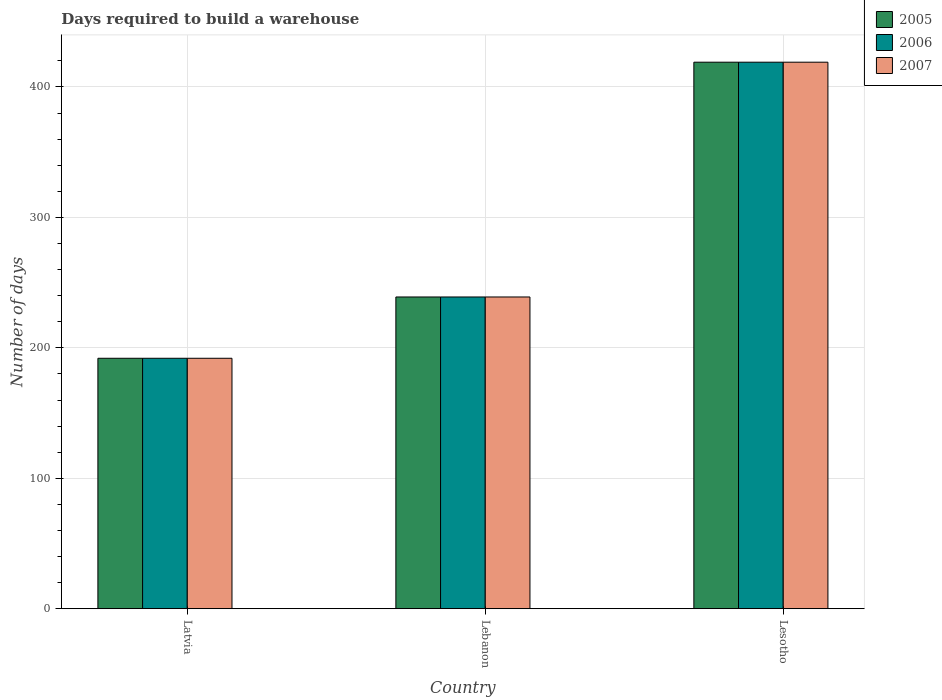How many groups of bars are there?
Give a very brief answer. 3. Are the number of bars on each tick of the X-axis equal?
Your answer should be compact. Yes. How many bars are there on the 3rd tick from the left?
Make the answer very short. 3. How many bars are there on the 2nd tick from the right?
Make the answer very short. 3. What is the label of the 1st group of bars from the left?
Ensure brevity in your answer.  Latvia. What is the days required to build a warehouse in in 2006 in Lebanon?
Provide a short and direct response. 239. Across all countries, what is the maximum days required to build a warehouse in in 2006?
Offer a very short reply. 419. Across all countries, what is the minimum days required to build a warehouse in in 2007?
Your response must be concise. 192. In which country was the days required to build a warehouse in in 2005 maximum?
Keep it short and to the point. Lesotho. In which country was the days required to build a warehouse in in 2006 minimum?
Offer a very short reply. Latvia. What is the total days required to build a warehouse in in 2006 in the graph?
Offer a very short reply. 850. What is the difference between the days required to build a warehouse in in 2007 in Latvia and that in Lesotho?
Keep it short and to the point. -227. What is the difference between the days required to build a warehouse in in 2007 in Lebanon and the days required to build a warehouse in in 2006 in Latvia?
Give a very brief answer. 47. What is the average days required to build a warehouse in in 2005 per country?
Ensure brevity in your answer.  283.33. What is the difference between the days required to build a warehouse in of/in 2006 and days required to build a warehouse in of/in 2007 in Lesotho?
Your answer should be very brief. 0. What is the ratio of the days required to build a warehouse in in 2005 in Lebanon to that in Lesotho?
Your response must be concise. 0.57. Is the difference between the days required to build a warehouse in in 2006 in Latvia and Lebanon greater than the difference between the days required to build a warehouse in in 2007 in Latvia and Lebanon?
Make the answer very short. No. What is the difference between the highest and the second highest days required to build a warehouse in in 2006?
Keep it short and to the point. -227. What is the difference between the highest and the lowest days required to build a warehouse in in 2005?
Your answer should be very brief. 227. In how many countries, is the days required to build a warehouse in in 2006 greater than the average days required to build a warehouse in in 2006 taken over all countries?
Offer a terse response. 1. What does the 1st bar from the left in Lesotho represents?
Your response must be concise. 2005. What does the 3rd bar from the right in Lesotho represents?
Offer a terse response. 2005. How many bars are there?
Your answer should be very brief. 9. How many countries are there in the graph?
Offer a very short reply. 3. Does the graph contain any zero values?
Keep it short and to the point. No. Does the graph contain grids?
Give a very brief answer. Yes. What is the title of the graph?
Your response must be concise. Days required to build a warehouse. What is the label or title of the X-axis?
Provide a short and direct response. Country. What is the label or title of the Y-axis?
Your answer should be very brief. Number of days. What is the Number of days in 2005 in Latvia?
Provide a short and direct response. 192. What is the Number of days in 2006 in Latvia?
Provide a succinct answer. 192. What is the Number of days in 2007 in Latvia?
Ensure brevity in your answer.  192. What is the Number of days in 2005 in Lebanon?
Ensure brevity in your answer.  239. What is the Number of days in 2006 in Lebanon?
Offer a very short reply. 239. What is the Number of days of 2007 in Lebanon?
Make the answer very short. 239. What is the Number of days of 2005 in Lesotho?
Make the answer very short. 419. What is the Number of days in 2006 in Lesotho?
Provide a succinct answer. 419. What is the Number of days of 2007 in Lesotho?
Give a very brief answer. 419. Across all countries, what is the maximum Number of days of 2005?
Provide a succinct answer. 419. Across all countries, what is the maximum Number of days in 2006?
Your answer should be very brief. 419. Across all countries, what is the maximum Number of days in 2007?
Provide a short and direct response. 419. Across all countries, what is the minimum Number of days of 2005?
Your response must be concise. 192. Across all countries, what is the minimum Number of days of 2006?
Offer a very short reply. 192. Across all countries, what is the minimum Number of days of 2007?
Offer a very short reply. 192. What is the total Number of days in 2005 in the graph?
Provide a succinct answer. 850. What is the total Number of days in 2006 in the graph?
Provide a succinct answer. 850. What is the total Number of days in 2007 in the graph?
Your answer should be compact. 850. What is the difference between the Number of days of 2005 in Latvia and that in Lebanon?
Make the answer very short. -47. What is the difference between the Number of days in 2006 in Latvia and that in Lebanon?
Offer a terse response. -47. What is the difference between the Number of days in 2007 in Latvia and that in Lebanon?
Your response must be concise. -47. What is the difference between the Number of days of 2005 in Latvia and that in Lesotho?
Keep it short and to the point. -227. What is the difference between the Number of days of 2006 in Latvia and that in Lesotho?
Keep it short and to the point. -227. What is the difference between the Number of days in 2007 in Latvia and that in Lesotho?
Your answer should be compact. -227. What is the difference between the Number of days of 2005 in Lebanon and that in Lesotho?
Offer a very short reply. -180. What is the difference between the Number of days in 2006 in Lebanon and that in Lesotho?
Your answer should be very brief. -180. What is the difference between the Number of days in 2007 in Lebanon and that in Lesotho?
Give a very brief answer. -180. What is the difference between the Number of days in 2005 in Latvia and the Number of days in 2006 in Lebanon?
Provide a succinct answer. -47. What is the difference between the Number of days in 2005 in Latvia and the Number of days in 2007 in Lebanon?
Provide a short and direct response. -47. What is the difference between the Number of days in 2006 in Latvia and the Number of days in 2007 in Lebanon?
Your answer should be compact. -47. What is the difference between the Number of days in 2005 in Latvia and the Number of days in 2006 in Lesotho?
Your response must be concise. -227. What is the difference between the Number of days in 2005 in Latvia and the Number of days in 2007 in Lesotho?
Ensure brevity in your answer.  -227. What is the difference between the Number of days in 2006 in Latvia and the Number of days in 2007 in Lesotho?
Give a very brief answer. -227. What is the difference between the Number of days in 2005 in Lebanon and the Number of days in 2006 in Lesotho?
Your response must be concise. -180. What is the difference between the Number of days in 2005 in Lebanon and the Number of days in 2007 in Lesotho?
Your response must be concise. -180. What is the difference between the Number of days of 2006 in Lebanon and the Number of days of 2007 in Lesotho?
Give a very brief answer. -180. What is the average Number of days of 2005 per country?
Make the answer very short. 283.33. What is the average Number of days of 2006 per country?
Your answer should be compact. 283.33. What is the average Number of days in 2007 per country?
Keep it short and to the point. 283.33. What is the difference between the Number of days in 2005 and Number of days in 2006 in Latvia?
Your response must be concise. 0. What is the difference between the Number of days in 2005 and Number of days in 2007 in Latvia?
Your answer should be very brief. 0. What is the difference between the Number of days in 2005 and Number of days in 2007 in Lebanon?
Keep it short and to the point. 0. What is the difference between the Number of days of 2006 and Number of days of 2007 in Lebanon?
Provide a short and direct response. 0. What is the difference between the Number of days of 2005 and Number of days of 2006 in Lesotho?
Keep it short and to the point. 0. What is the difference between the Number of days in 2006 and Number of days in 2007 in Lesotho?
Offer a very short reply. 0. What is the ratio of the Number of days in 2005 in Latvia to that in Lebanon?
Ensure brevity in your answer.  0.8. What is the ratio of the Number of days of 2006 in Latvia to that in Lebanon?
Offer a very short reply. 0.8. What is the ratio of the Number of days in 2007 in Latvia to that in Lebanon?
Your answer should be compact. 0.8. What is the ratio of the Number of days of 2005 in Latvia to that in Lesotho?
Offer a terse response. 0.46. What is the ratio of the Number of days of 2006 in Latvia to that in Lesotho?
Your response must be concise. 0.46. What is the ratio of the Number of days of 2007 in Latvia to that in Lesotho?
Offer a terse response. 0.46. What is the ratio of the Number of days in 2005 in Lebanon to that in Lesotho?
Offer a terse response. 0.57. What is the ratio of the Number of days of 2006 in Lebanon to that in Lesotho?
Give a very brief answer. 0.57. What is the ratio of the Number of days of 2007 in Lebanon to that in Lesotho?
Offer a terse response. 0.57. What is the difference between the highest and the second highest Number of days in 2005?
Offer a very short reply. 180. What is the difference between the highest and the second highest Number of days of 2006?
Keep it short and to the point. 180. What is the difference between the highest and the second highest Number of days of 2007?
Keep it short and to the point. 180. What is the difference between the highest and the lowest Number of days of 2005?
Provide a short and direct response. 227. What is the difference between the highest and the lowest Number of days of 2006?
Offer a very short reply. 227. What is the difference between the highest and the lowest Number of days in 2007?
Your response must be concise. 227. 